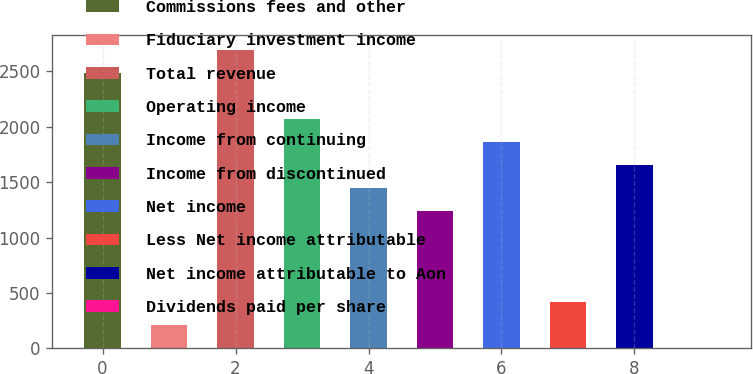Convert chart to OTSL. <chart><loc_0><loc_0><loc_500><loc_500><bar_chart><fcel>Commissions fees and other<fcel>Fiduciary investment income<fcel>Total revenue<fcel>Operating income<fcel>Income from continuing<fcel>Income from discontinued<fcel>Net income<fcel>Less Net income attributable<fcel>Net income attributable to Aon<fcel>Dividends paid per share<nl><fcel>2487.59<fcel>207.44<fcel>2694.88<fcel>2073.01<fcel>1451.15<fcel>1243.87<fcel>1865.73<fcel>414.73<fcel>1658.44<fcel>0.15<nl></chart> 